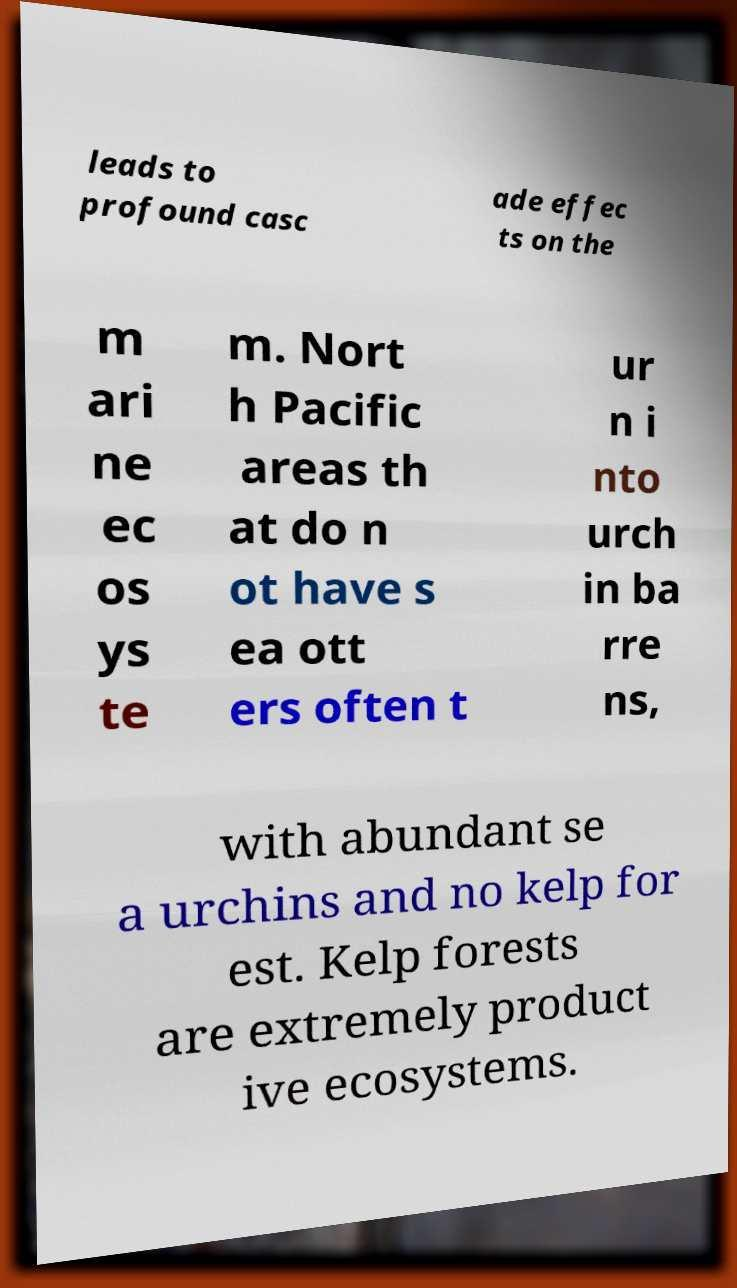Please read and relay the text visible in this image. What does it say? leads to profound casc ade effec ts on the m ari ne ec os ys te m. Nort h Pacific areas th at do n ot have s ea ott ers often t ur n i nto urch in ba rre ns, with abundant se a urchins and no kelp for est. Kelp forests are extremely product ive ecosystems. 